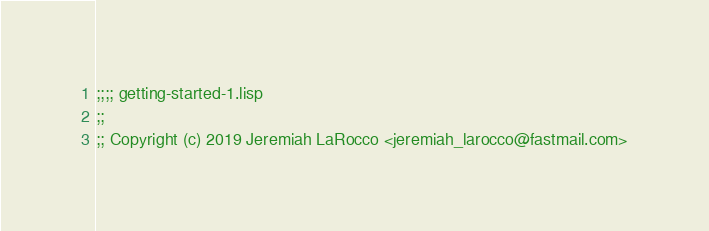Convert code to text. <code><loc_0><loc_0><loc_500><loc_500><_Lisp_>;;;; getting-started-1.lisp
;;
;; Copyright (c) 2019 Jeremiah LaRocco <jeremiah_larocco@fastmail.com>
</code> 